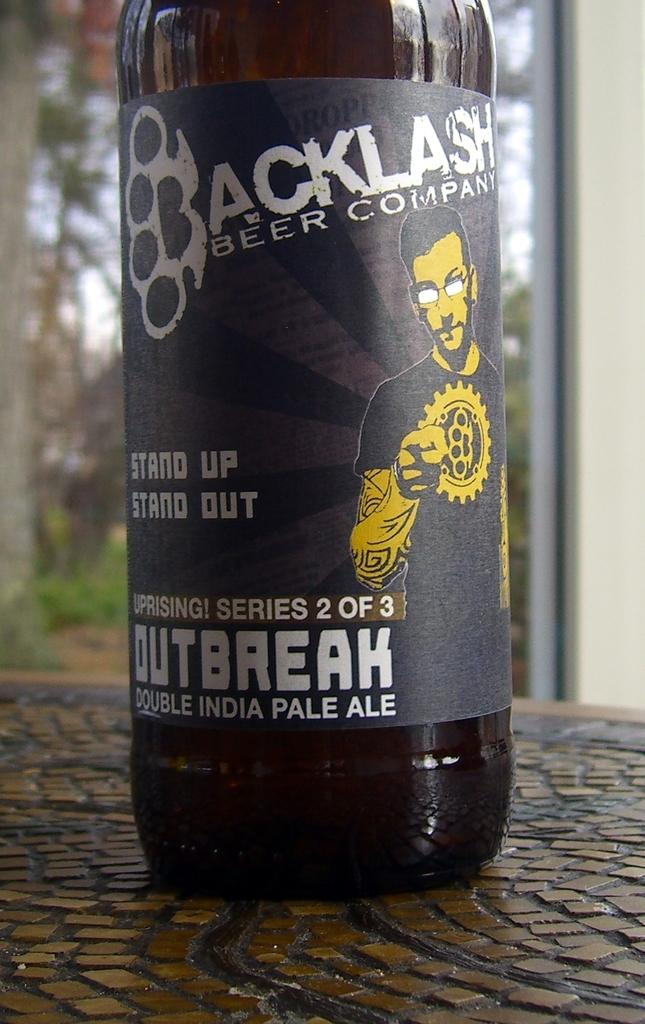<image>
Summarize the visual content of the image. A dark bottle of Backlash beer company with a man on it 